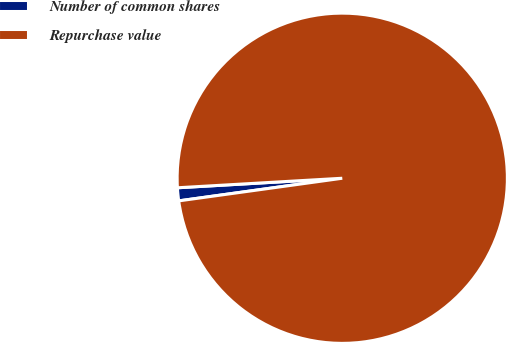Convert chart. <chart><loc_0><loc_0><loc_500><loc_500><pie_chart><fcel>Number of common shares<fcel>Repurchase value<nl><fcel>1.27%<fcel>98.73%<nl></chart> 